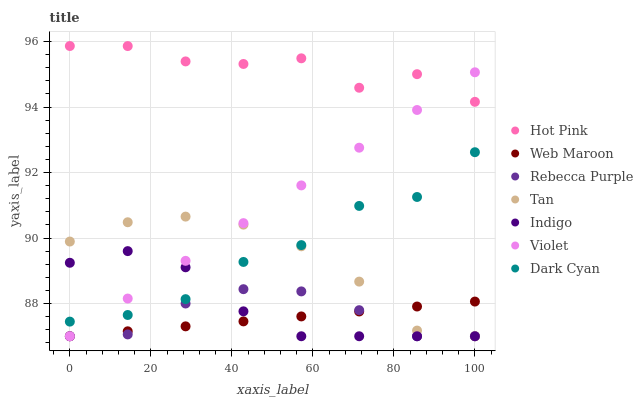Does Web Maroon have the minimum area under the curve?
Answer yes or no. Yes. Does Hot Pink have the maximum area under the curve?
Answer yes or no. Yes. Does Hot Pink have the minimum area under the curve?
Answer yes or no. No. Does Web Maroon have the maximum area under the curve?
Answer yes or no. No. Is Web Maroon the smoothest?
Answer yes or no. Yes. Is Hot Pink the roughest?
Answer yes or no. Yes. Is Hot Pink the smoothest?
Answer yes or no. No. Is Web Maroon the roughest?
Answer yes or no. No. Does Indigo have the lowest value?
Answer yes or no. Yes. Does Hot Pink have the lowest value?
Answer yes or no. No. Does Hot Pink have the highest value?
Answer yes or no. Yes. Does Web Maroon have the highest value?
Answer yes or no. No. Is Dark Cyan less than Hot Pink?
Answer yes or no. Yes. Is Dark Cyan greater than Rebecca Purple?
Answer yes or no. Yes. Does Web Maroon intersect Rebecca Purple?
Answer yes or no. Yes. Is Web Maroon less than Rebecca Purple?
Answer yes or no. No. Is Web Maroon greater than Rebecca Purple?
Answer yes or no. No. Does Dark Cyan intersect Hot Pink?
Answer yes or no. No. 